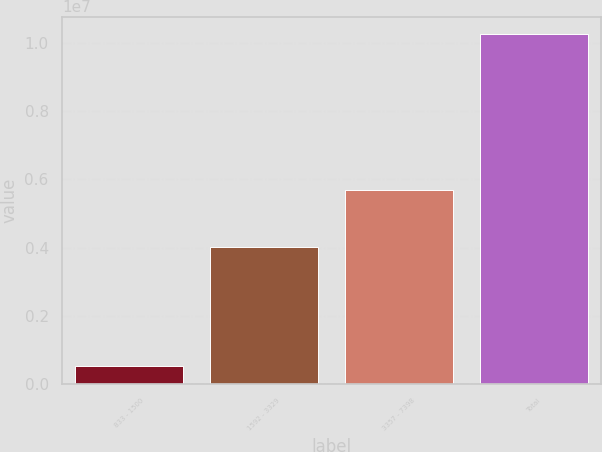Convert chart to OTSL. <chart><loc_0><loc_0><loc_500><loc_500><bar_chart><fcel>833 - 1500<fcel>1592 - 3329<fcel>3357 - 7398<fcel>Total<nl><fcel>549519<fcel>4.0282e+06<fcel>5.67826e+06<fcel>1.0256e+07<nl></chart> 